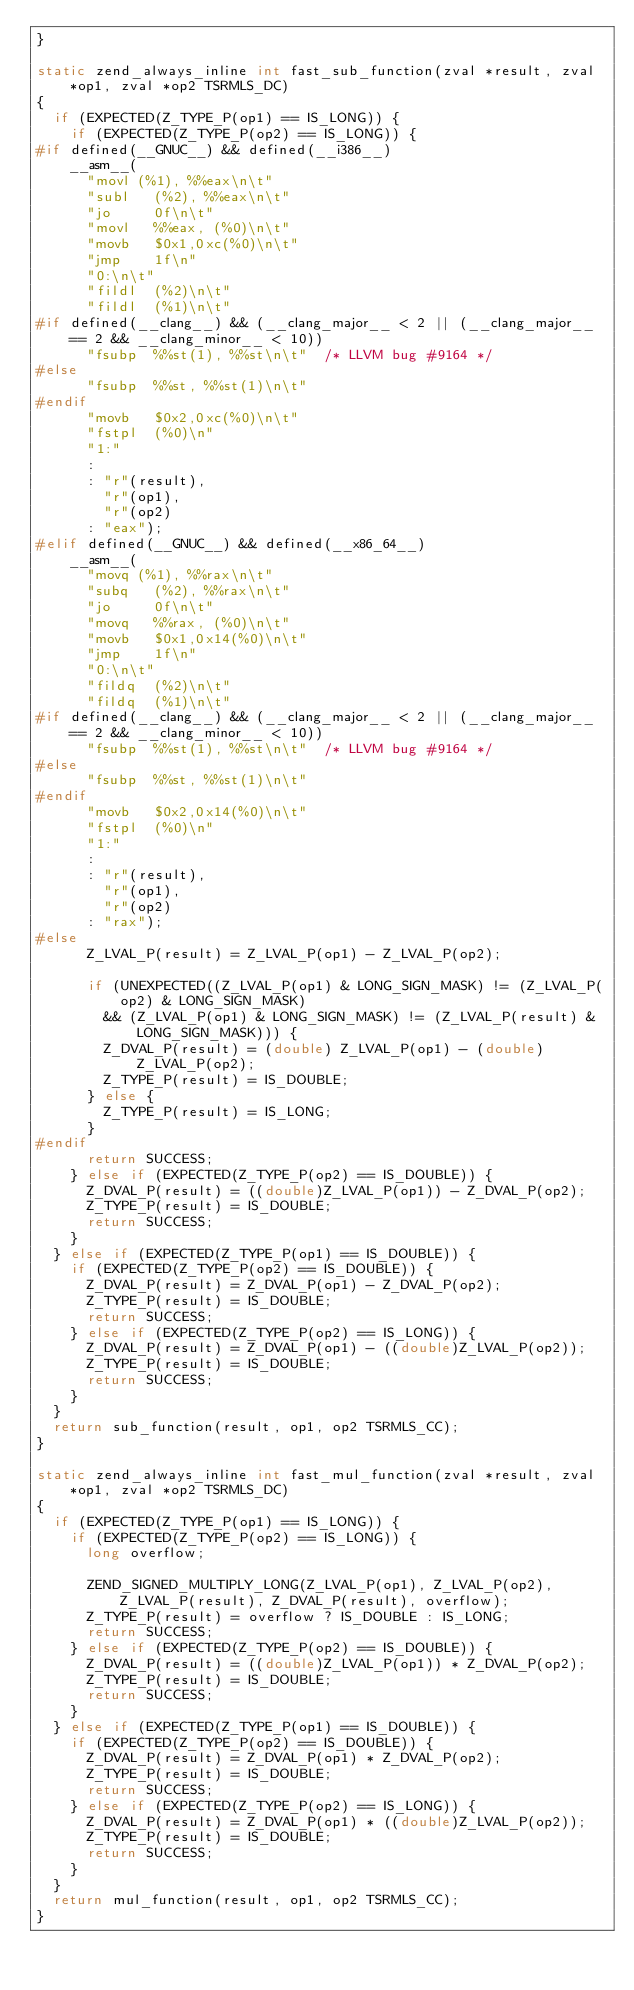Convert code to text. <code><loc_0><loc_0><loc_500><loc_500><_C_>}

static zend_always_inline int fast_sub_function(zval *result, zval *op1, zval *op2 TSRMLS_DC)
{
	if (EXPECTED(Z_TYPE_P(op1) == IS_LONG)) {
		if (EXPECTED(Z_TYPE_P(op2) == IS_LONG)) {
#if defined(__GNUC__) && defined(__i386__)
		__asm__(
			"movl	(%1), %%eax\n\t"
			"subl   (%2), %%eax\n\t"
			"jo     0f\n\t"     
			"movl   %%eax, (%0)\n\t"
			"movb   $0x1,0xc(%0)\n\t"
			"jmp    1f\n"
			"0:\n\t"
			"fildl	(%2)\n\t"
			"fildl	(%1)\n\t"
#if defined(__clang__) && (__clang_major__ < 2 || (__clang_major__ == 2 && __clang_minor__ < 10))
			"fsubp  %%st(1), %%st\n\t"  /* LLVM bug #9164 */
#else
			"fsubp	%%st, %%st(1)\n\t"
#endif
			"movb   $0x2,0xc(%0)\n\t"
			"fstpl	(%0)\n"
			"1:"
			: 
			: "r"(result),
			  "r"(op1),
			  "r"(op2)
			: "eax");
#elif defined(__GNUC__) && defined(__x86_64__)
		__asm__(
			"movq	(%1), %%rax\n\t"
			"subq   (%2), %%rax\n\t"
			"jo     0f\n\t"     
			"movq   %%rax, (%0)\n\t"
			"movb   $0x1,0x14(%0)\n\t"
			"jmp    1f\n"
			"0:\n\t"
			"fildq	(%2)\n\t"
			"fildq	(%1)\n\t"
#if defined(__clang__) && (__clang_major__ < 2 || (__clang_major__ == 2 && __clang_minor__ < 10))
			"fsubp  %%st(1), %%st\n\t"  /* LLVM bug #9164 */
#else
			"fsubp	%%st, %%st(1)\n\t"
#endif
			"movb   $0x2,0x14(%0)\n\t"
			"fstpl	(%0)\n"
			"1:"
			: 
			: "r"(result),
			  "r"(op1),
			  "r"(op2)
			: "rax");
#else
			Z_LVAL_P(result) = Z_LVAL_P(op1) - Z_LVAL_P(op2);

			if (UNEXPECTED((Z_LVAL_P(op1) & LONG_SIGN_MASK) != (Z_LVAL_P(op2) & LONG_SIGN_MASK)
				&& (Z_LVAL_P(op1) & LONG_SIGN_MASK) != (Z_LVAL_P(result) & LONG_SIGN_MASK))) {
				Z_DVAL_P(result) = (double) Z_LVAL_P(op1) - (double) Z_LVAL_P(op2);
				Z_TYPE_P(result) = IS_DOUBLE;
			} else {
				Z_TYPE_P(result) = IS_LONG;
			}
#endif
			return SUCCESS;
		} else if (EXPECTED(Z_TYPE_P(op2) == IS_DOUBLE)) {
			Z_DVAL_P(result) = ((double)Z_LVAL_P(op1)) - Z_DVAL_P(op2);
			Z_TYPE_P(result) = IS_DOUBLE;
			return SUCCESS;
		}
	} else if (EXPECTED(Z_TYPE_P(op1) == IS_DOUBLE)) {
		if (EXPECTED(Z_TYPE_P(op2) == IS_DOUBLE)) {
			Z_DVAL_P(result) = Z_DVAL_P(op1) - Z_DVAL_P(op2);
			Z_TYPE_P(result) = IS_DOUBLE;
			return SUCCESS;
		} else if (EXPECTED(Z_TYPE_P(op2) == IS_LONG)) {
			Z_DVAL_P(result) = Z_DVAL_P(op1) - ((double)Z_LVAL_P(op2));
			Z_TYPE_P(result) = IS_DOUBLE;
			return SUCCESS;
		}
	}
	return sub_function(result, op1, op2 TSRMLS_CC);
}

static zend_always_inline int fast_mul_function(zval *result, zval *op1, zval *op2 TSRMLS_DC)
{
	if (EXPECTED(Z_TYPE_P(op1) == IS_LONG)) {
		if (EXPECTED(Z_TYPE_P(op2) == IS_LONG)) {
			long overflow;

			ZEND_SIGNED_MULTIPLY_LONG(Z_LVAL_P(op1), Z_LVAL_P(op2), Z_LVAL_P(result), Z_DVAL_P(result), overflow);
			Z_TYPE_P(result) = overflow ? IS_DOUBLE : IS_LONG;
			return SUCCESS;
		} else if (EXPECTED(Z_TYPE_P(op2) == IS_DOUBLE)) {
			Z_DVAL_P(result) = ((double)Z_LVAL_P(op1)) * Z_DVAL_P(op2);
			Z_TYPE_P(result) = IS_DOUBLE;
			return SUCCESS;
		}
	} else if (EXPECTED(Z_TYPE_P(op1) == IS_DOUBLE)) {
		if (EXPECTED(Z_TYPE_P(op2) == IS_DOUBLE)) {
			Z_DVAL_P(result) = Z_DVAL_P(op1) * Z_DVAL_P(op2);
			Z_TYPE_P(result) = IS_DOUBLE;
			return SUCCESS;
		} else if (EXPECTED(Z_TYPE_P(op2) == IS_LONG)) {
			Z_DVAL_P(result) = Z_DVAL_P(op1) * ((double)Z_LVAL_P(op2));
			Z_TYPE_P(result) = IS_DOUBLE;
			return SUCCESS;
		}
	}
	return mul_function(result, op1, op2 TSRMLS_CC);
}
</code> 